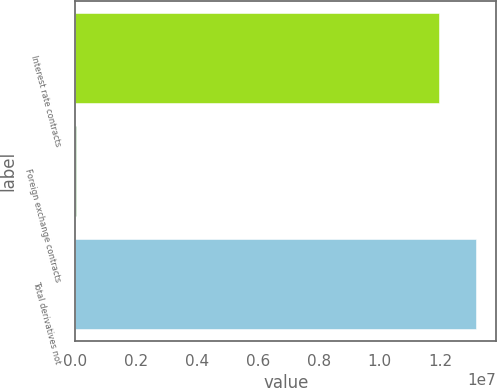<chart> <loc_0><loc_0><loc_500><loc_500><bar_chart><fcel>Interest rate contracts<fcel>Foreign exchange contracts<fcel>Total derivatives not<nl><fcel>1.19543e+07<fcel>10505<fcel>1.31711e+07<nl></chart> 